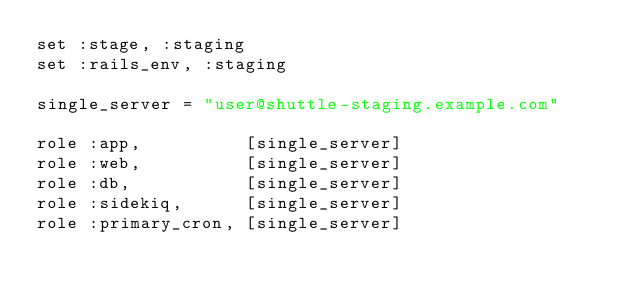Convert code to text. <code><loc_0><loc_0><loc_500><loc_500><_Ruby_>set :stage, :staging
set :rails_env, :staging

single_server = "user@shuttle-staging.example.com"

role :app,          [single_server]
role :web,          [single_server]
role :db,           [single_server]
role :sidekiq,      [single_server]
role :primary_cron, [single_server]
</code> 